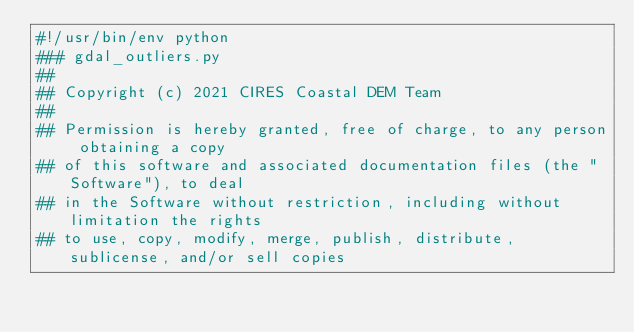Convert code to text. <code><loc_0><loc_0><loc_500><loc_500><_Python_>#!/usr/bin/env python
### gdal_outliers.py
##
## Copyright (c) 2021 CIRES Coastal DEM Team
##
## Permission is hereby granted, free of charge, to any person obtaining a copy 
## of this software and associated documentation files (the "Software"), to deal 
## in the Software without restriction, including without limitation the rights 
## to use, copy, modify, merge, publish, distribute, sublicense, and/or sell copies </code> 